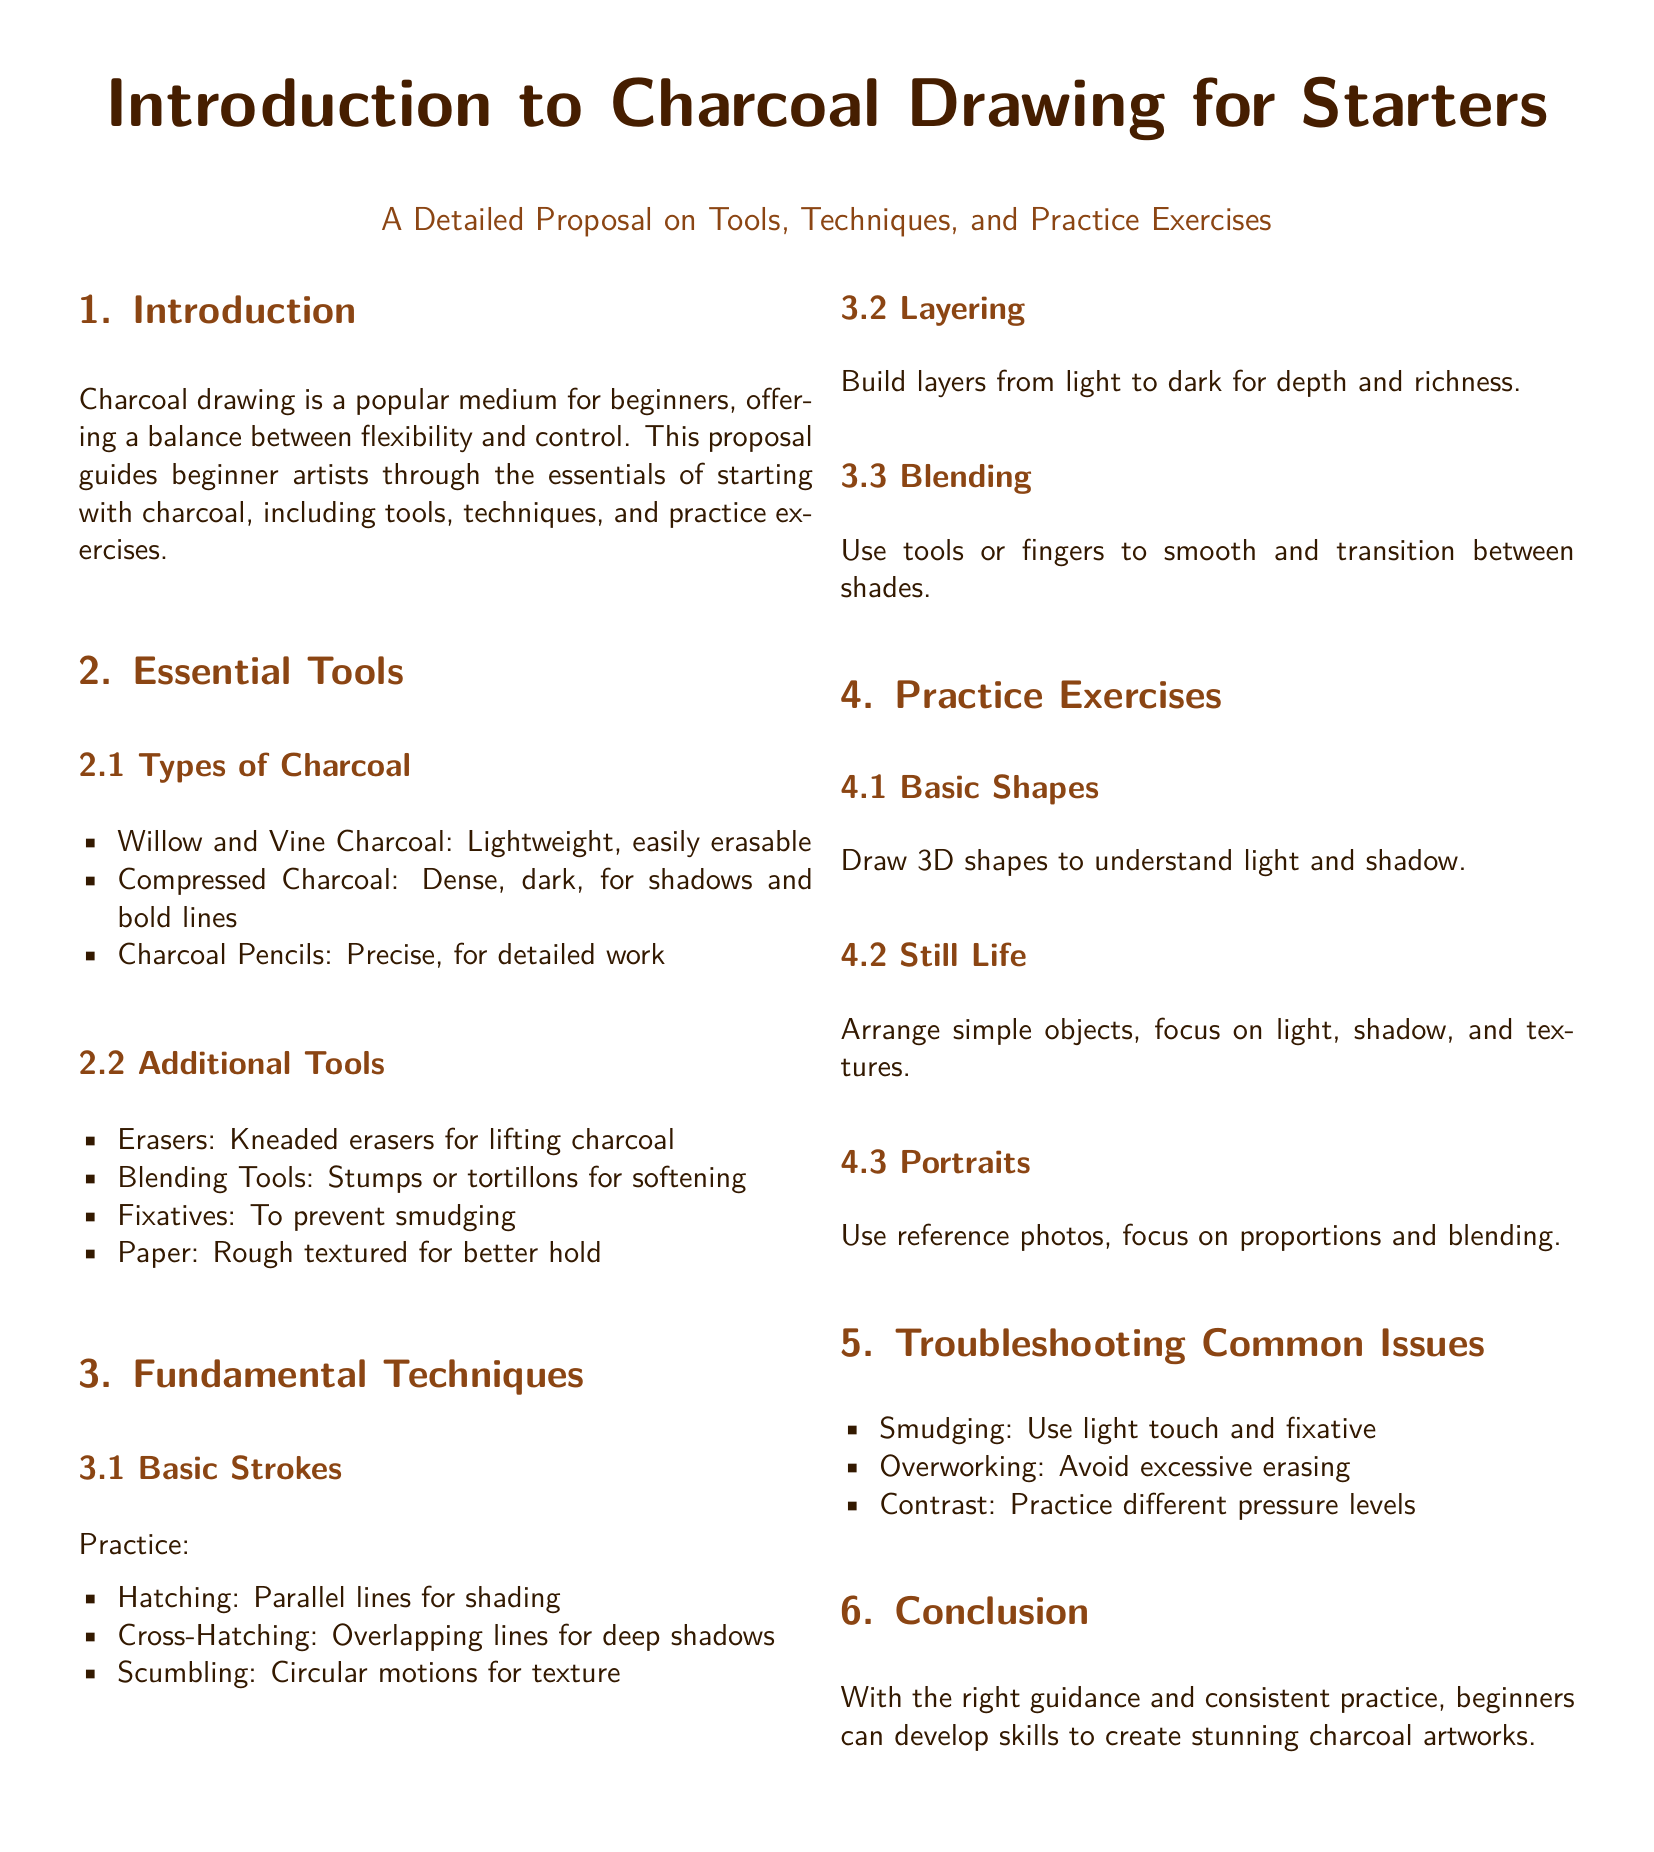What are the types of charcoal mentioned? The document lists different types of charcoal including willow, vine, compressed, and charcoal pencils.
Answer: Willow and Vine Charcoal, Compressed Charcoal, Charcoal Pencils What is the main purpose of this proposal? The main purpose is to guide beginner artists through the essentials of starting with charcoal, including tools, techniques, and practice exercises.
Answer: To guide beginner artists What is a recommended blending tool? The document mentions stumps or tortillons as blending tools for softening the charcoal.
Answer: Stumps or tortillons What should you avoid to prevent smudging? Using a light touch and applying fixative are recommended to prevent smudging in charcoal drawing.
Answer: Light touch and fixative What is the first practice exercise suggested? The document suggests drawing 3D shapes as the first practice exercise to understand light and shadow.
Answer: Basic Shapes What are the three fundamental techniques listed? Basic strokes include hatching, cross-hatching, and scumbling as fundamental techniques.
Answer: Hatching, Cross-Hatching, Scumbling What issue is associated with overworking the charcoal? Overworking can lead to excessive erasing, which is mentioned as a common issue in the document.
Answer: Excessive erasing How should layers be built for depth? The document states that layers should be built from light to dark to achieve depth and richness in a drawing.
Answer: Light to dark 